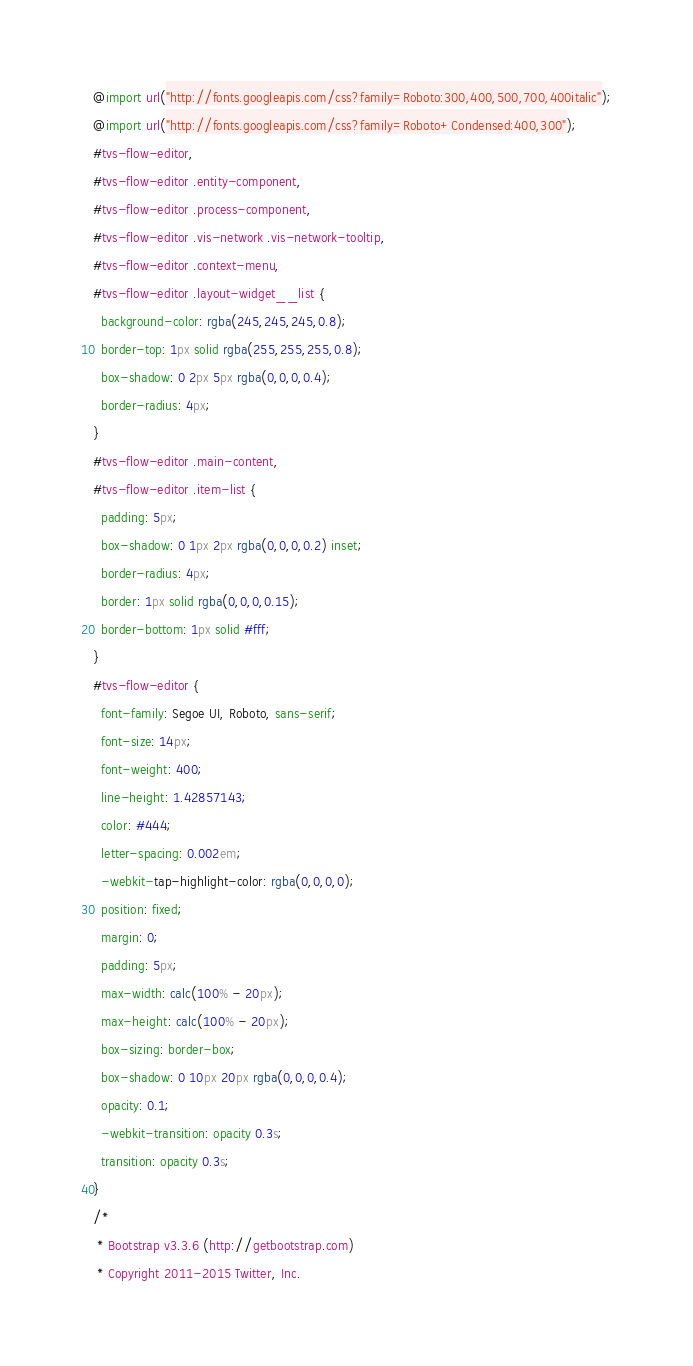Convert code to text. <code><loc_0><loc_0><loc_500><loc_500><_CSS_>@import url("http://fonts.googleapis.com/css?family=Roboto:300,400,500,700,400italic");
@import url("http://fonts.googleapis.com/css?family=Roboto+Condensed:400,300");
#tvs-flow-editor,
#tvs-flow-editor .entity-component,
#tvs-flow-editor .process-component,
#tvs-flow-editor .vis-network .vis-network-tooltip,
#tvs-flow-editor .context-menu,
#tvs-flow-editor .layout-widget__list {
  background-color: rgba(245,245,245,0.8);
  border-top: 1px solid rgba(255,255,255,0.8);
  box-shadow: 0 2px 5px rgba(0,0,0,0.4);
  border-radius: 4px;
}
#tvs-flow-editor .main-content,
#tvs-flow-editor .item-list {
  padding: 5px;
  box-shadow: 0 1px 2px rgba(0,0,0,0.2) inset;
  border-radius: 4px;
  border: 1px solid rgba(0,0,0,0.15);
  border-bottom: 1px solid #fff;
}
#tvs-flow-editor {
  font-family: Segoe UI, Roboto, sans-serif;
  font-size: 14px;
  font-weight: 400;
  line-height: 1.42857143;
  color: #444;
  letter-spacing: 0.002em;
  -webkit-tap-highlight-color: rgba(0,0,0,0);
  position: fixed;
  margin: 0;
  padding: 5px;
  max-width: calc(100% - 20px);
  max-height: calc(100% - 20px);
  box-sizing: border-box;
  box-shadow: 0 10px 20px rgba(0,0,0,0.4);
  opacity: 0.1;
  -webkit-transition: opacity 0.3s;
  transition: opacity 0.3s;
}
/*
 * Bootstrap v3.3.6 (http://getbootstrap.com)
 * Copyright 2011-2015 Twitter, Inc.</code> 